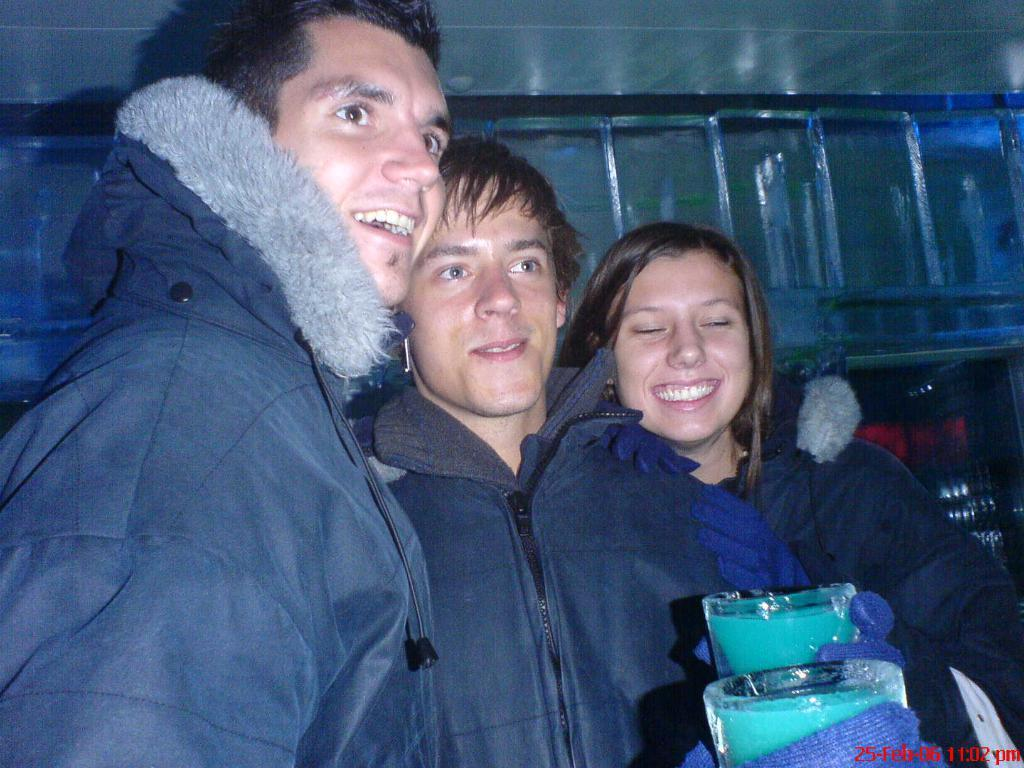How many people are present in the image? There are three persons standing in the image. What are two of the persons holding? Two of the persons are holding objects that look like glass. What can be seen in the background of the image? There is an iron railing in the background of the image. How many snails are crawling on the persons in the image? There are no snails present in the image; the persons are not interacting with any snails. 